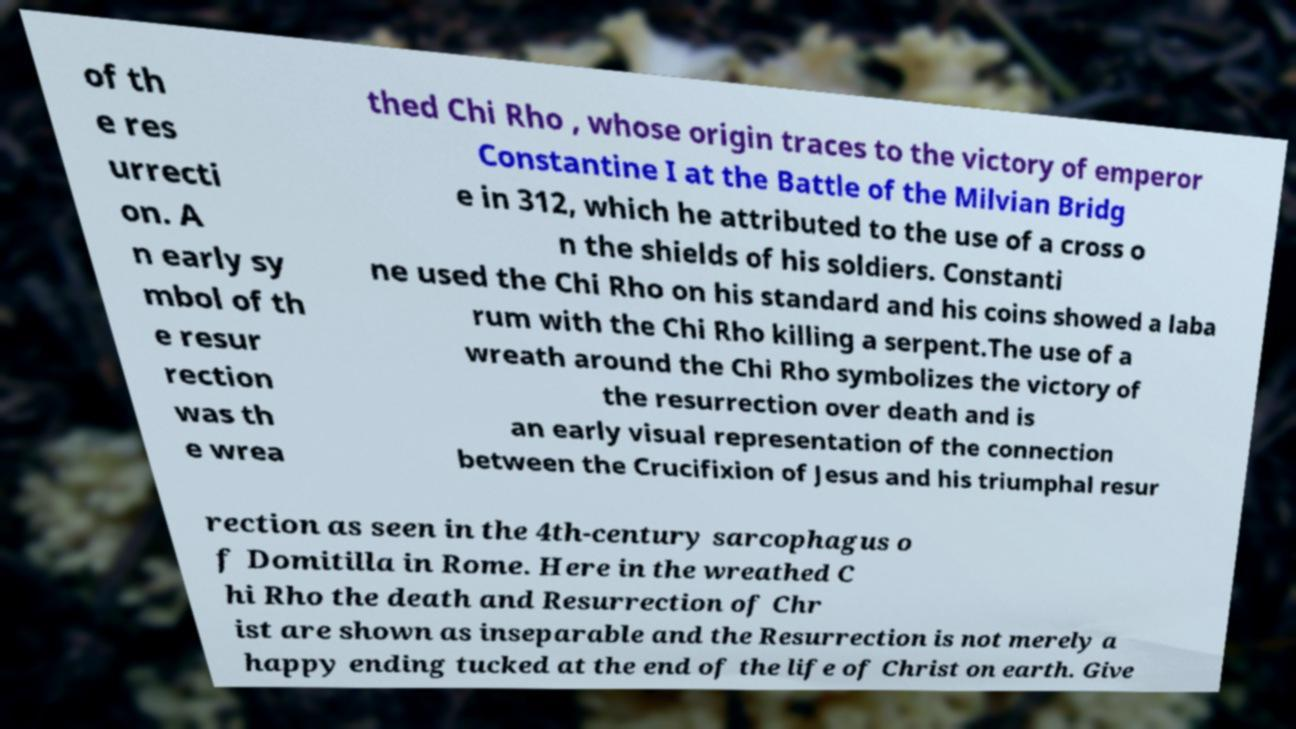I need the written content from this picture converted into text. Can you do that? of th e res urrecti on. A n early sy mbol of th e resur rection was th e wrea thed Chi Rho , whose origin traces to the victory of emperor Constantine I at the Battle of the Milvian Bridg e in 312, which he attributed to the use of a cross o n the shields of his soldiers. Constanti ne used the Chi Rho on his standard and his coins showed a laba rum with the Chi Rho killing a serpent.The use of a wreath around the Chi Rho symbolizes the victory of the resurrection over death and is an early visual representation of the connection between the Crucifixion of Jesus and his triumphal resur rection as seen in the 4th-century sarcophagus o f Domitilla in Rome. Here in the wreathed C hi Rho the death and Resurrection of Chr ist are shown as inseparable and the Resurrection is not merely a happy ending tucked at the end of the life of Christ on earth. Give 